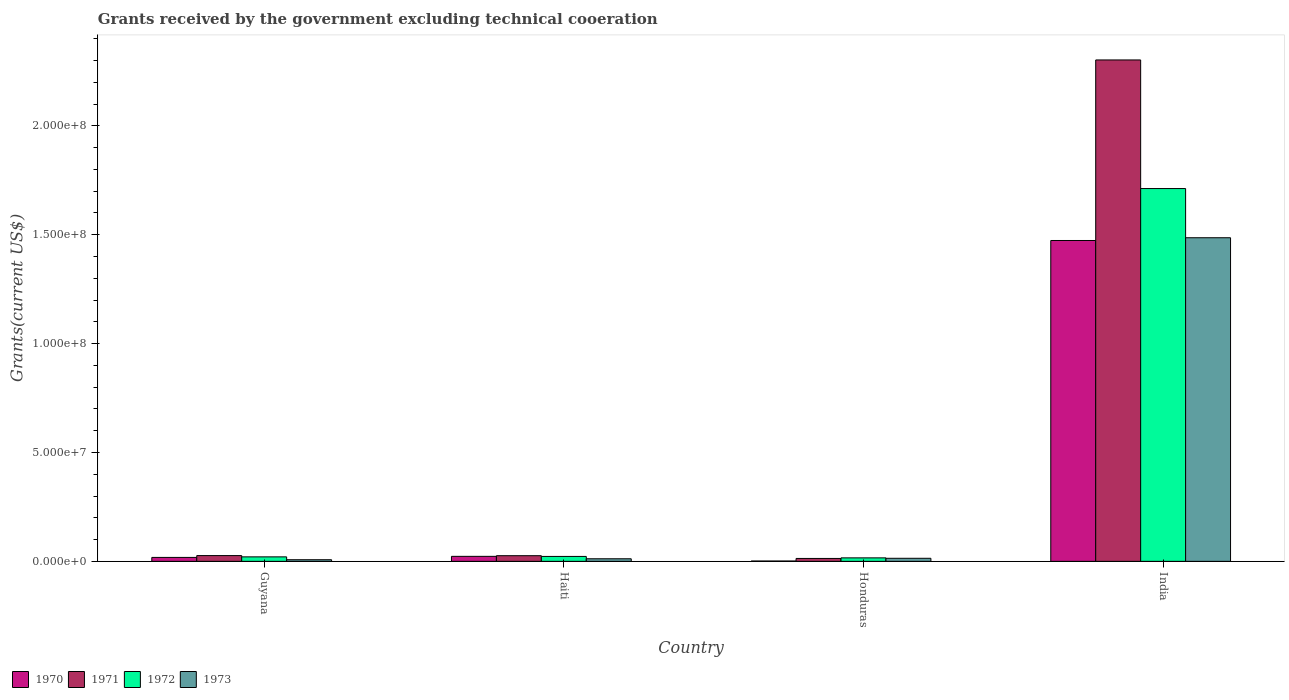How many different coloured bars are there?
Offer a very short reply. 4. What is the label of the 1st group of bars from the left?
Provide a succinct answer. Guyana. In how many cases, is the number of bars for a given country not equal to the number of legend labels?
Your answer should be compact. 0. What is the total grants received by the government in 1973 in Haiti?
Provide a short and direct response. 1.19e+06. Across all countries, what is the maximum total grants received by the government in 1973?
Your answer should be compact. 1.49e+08. Across all countries, what is the minimum total grants received by the government in 1971?
Your response must be concise. 1.34e+06. In which country was the total grants received by the government in 1973 maximum?
Provide a short and direct response. India. In which country was the total grants received by the government in 1973 minimum?
Make the answer very short. Guyana. What is the total total grants received by the government in 1970 in the graph?
Your response must be concise. 1.52e+08. What is the difference between the total grants received by the government in 1971 in Haiti and that in India?
Your answer should be very brief. -2.28e+08. What is the difference between the total grants received by the government in 1971 in Haiti and the total grants received by the government in 1972 in India?
Give a very brief answer. -1.69e+08. What is the average total grants received by the government in 1973 per country?
Provide a short and direct response. 3.80e+07. What is the ratio of the total grants received by the government in 1971 in Honduras to that in India?
Provide a short and direct response. 0.01. Is the total grants received by the government in 1971 in Guyana less than that in Haiti?
Give a very brief answer. No. What is the difference between the highest and the second highest total grants received by the government in 1973?
Offer a very short reply. 1.47e+08. What is the difference between the highest and the lowest total grants received by the government in 1972?
Provide a short and direct response. 1.70e+08. In how many countries, is the total grants received by the government in 1973 greater than the average total grants received by the government in 1973 taken over all countries?
Your answer should be very brief. 1. Is the sum of the total grants received by the government in 1971 in Haiti and India greater than the maximum total grants received by the government in 1972 across all countries?
Provide a short and direct response. Yes. How many bars are there?
Ensure brevity in your answer.  16. How many countries are there in the graph?
Provide a succinct answer. 4. What is the difference between two consecutive major ticks on the Y-axis?
Offer a very short reply. 5.00e+07. How many legend labels are there?
Give a very brief answer. 4. What is the title of the graph?
Offer a terse response. Grants received by the government excluding technical cooeration. What is the label or title of the Y-axis?
Ensure brevity in your answer.  Grants(current US$). What is the Grants(current US$) of 1970 in Guyana?
Give a very brief answer. 1.81e+06. What is the Grants(current US$) in 1971 in Guyana?
Your answer should be compact. 2.65e+06. What is the Grants(current US$) in 1972 in Guyana?
Your response must be concise. 2.06e+06. What is the Grants(current US$) in 1973 in Guyana?
Make the answer very short. 7.50e+05. What is the Grants(current US$) in 1970 in Haiti?
Provide a short and direct response. 2.30e+06. What is the Grants(current US$) in 1971 in Haiti?
Keep it short and to the point. 2.60e+06. What is the Grants(current US$) of 1972 in Haiti?
Provide a succinct answer. 2.26e+06. What is the Grants(current US$) in 1973 in Haiti?
Offer a very short reply. 1.19e+06. What is the Grants(current US$) in 1970 in Honduras?
Your answer should be very brief. 1.60e+05. What is the Grants(current US$) of 1971 in Honduras?
Make the answer very short. 1.34e+06. What is the Grants(current US$) of 1972 in Honduras?
Provide a short and direct response. 1.60e+06. What is the Grants(current US$) in 1973 in Honduras?
Provide a succinct answer. 1.41e+06. What is the Grants(current US$) of 1970 in India?
Make the answer very short. 1.47e+08. What is the Grants(current US$) of 1971 in India?
Provide a succinct answer. 2.30e+08. What is the Grants(current US$) in 1972 in India?
Give a very brief answer. 1.71e+08. What is the Grants(current US$) of 1973 in India?
Offer a very short reply. 1.49e+08. Across all countries, what is the maximum Grants(current US$) of 1970?
Your answer should be compact. 1.47e+08. Across all countries, what is the maximum Grants(current US$) in 1971?
Ensure brevity in your answer.  2.30e+08. Across all countries, what is the maximum Grants(current US$) of 1972?
Your response must be concise. 1.71e+08. Across all countries, what is the maximum Grants(current US$) of 1973?
Give a very brief answer. 1.49e+08. Across all countries, what is the minimum Grants(current US$) of 1970?
Ensure brevity in your answer.  1.60e+05. Across all countries, what is the minimum Grants(current US$) of 1971?
Give a very brief answer. 1.34e+06. Across all countries, what is the minimum Grants(current US$) in 1972?
Provide a short and direct response. 1.60e+06. Across all countries, what is the minimum Grants(current US$) in 1973?
Your response must be concise. 7.50e+05. What is the total Grants(current US$) in 1970 in the graph?
Your answer should be compact. 1.52e+08. What is the total Grants(current US$) in 1971 in the graph?
Provide a succinct answer. 2.37e+08. What is the total Grants(current US$) of 1972 in the graph?
Keep it short and to the point. 1.77e+08. What is the total Grants(current US$) in 1973 in the graph?
Offer a very short reply. 1.52e+08. What is the difference between the Grants(current US$) of 1970 in Guyana and that in Haiti?
Your answer should be very brief. -4.90e+05. What is the difference between the Grants(current US$) in 1971 in Guyana and that in Haiti?
Provide a succinct answer. 5.00e+04. What is the difference between the Grants(current US$) in 1973 in Guyana and that in Haiti?
Your response must be concise. -4.40e+05. What is the difference between the Grants(current US$) in 1970 in Guyana and that in Honduras?
Provide a short and direct response. 1.65e+06. What is the difference between the Grants(current US$) in 1971 in Guyana and that in Honduras?
Make the answer very short. 1.31e+06. What is the difference between the Grants(current US$) in 1973 in Guyana and that in Honduras?
Your answer should be very brief. -6.60e+05. What is the difference between the Grants(current US$) of 1970 in Guyana and that in India?
Give a very brief answer. -1.46e+08. What is the difference between the Grants(current US$) of 1971 in Guyana and that in India?
Your response must be concise. -2.28e+08. What is the difference between the Grants(current US$) in 1972 in Guyana and that in India?
Provide a succinct answer. -1.69e+08. What is the difference between the Grants(current US$) of 1973 in Guyana and that in India?
Offer a very short reply. -1.48e+08. What is the difference between the Grants(current US$) in 1970 in Haiti and that in Honduras?
Offer a terse response. 2.14e+06. What is the difference between the Grants(current US$) in 1971 in Haiti and that in Honduras?
Provide a succinct answer. 1.26e+06. What is the difference between the Grants(current US$) of 1972 in Haiti and that in Honduras?
Make the answer very short. 6.60e+05. What is the difference between the Grants(current US$) of 1970 in Haiti and that in India?
Your response must be concise. -1.45e+08. What is the difference between the Grants(current US$) of 1971 in Haiti and that in India?
Your answer should be compact. -2.28e+08. What is the difference between the Grants(current US$) of 1972 in Haiti and that in India?
Provide a short and direct response. -1.69e+08. What is the difference between the Grants(current US$) of 1973 in Haiti and that in India?
Give a very brief answer. -1.47e+08. What is the difference between the Grants(current US$) in 1970 in Honduras and that in India?
Offer a terse response. -1.47e+08. What is the difference between the Grants(current US$) of 1971 in Honduras and that in India?
Your answer should be very brief. -2.29e+08. What is the difference between the Grants(current US$) of 1972 in Honduras and that in India?
Give a very brief answer. -1.70e+08. What is the difference between the Grants(current US$) of 1973 in Honduras and that in India?
Keep it short and to the point. -1.47e+08. What is the difference between the Grants(current US$) of 1970 in Guyana and the Grants(current US$) of 1971 in Haiti?
Give a very brief answer. -7.90e+05. What is the difference between the Grants(current US$) in 1970 in Guyana and the Grants(current US$) in 1972 in Haiti?
Give a very brief answer. -4.50e+05. What is the difference between the Grants(current US$) of 1970 in Guyana and the Grants(current US$) of 1973 in Haiti?
Give a very brief answer. 6.20e+05. What is the difference between the Grants(current US$) in 1971 in Guyana and the Grants(current US$) in 1973 in Haiti?
Your answer should be very brief. 1.46e+06. What is the difference between the Grants(current US$) of 1972 in Guyana and the Grants(current US$) of 1973 in Haiti?
Provide a short and direct response. 8.70e+05. What is the difference between the Grants(current US$) of 1970 in Guyana and the Grants(current US$) of 1972 in Honduras?
Your answer should be compact. 2.10e+05. What is the difference between the Grants(current US$) of 1970 in Guyana and the Grants(current US$) of 1973 in Honduras?
Provide a succinct answer. 4.00e+05. What is the difference between the Grants(current US$) in 1971 in Guyana and the Grants(current US$) in 1972 in Honduras?
Make the answer very short. 1.05e+06. What is the difference between the Grants(current US$) in 1971 in Guyana and the Grants(current US$) in 1973 in Honduras?
Offer a very short reply. 1.24e+06. What is the difference between the Grants(current US$) in 1972 in Guyana and the Grants(current US$) in 1973 in Honduras?
Offer a terse response. 6.50e+05. What is the difference between the Grants(current US$) of 1970 in Guyana and the Grants(current US$) of 1971 in India?
Give a very brief answer. -2.28e+08. What is the difference between the Grants(current US$) of 1970 in Guyana and the Grants(current US$) of 1972 in India?
Offer a very short reply. -1.69e+08. What is the difference between the Grants(current US$) of 1970 in Guyana and the Grants(current US$) of 1973 in India?
Provide a succinct answer. -1.47e+08. What is the difference between the Grants(current US$) of 1971 in Guyana and the Grants(current US$) of 1972 in India?
Make the answer very short. -1.69e+08. What is the difference between the Grants(current US$) in 1971 in Guyana and the Grants(current US$) in 1973 in India?
Your answer should be compact. -1.46e+08. What is the difference between the Grants(current US$) of 1972 in Guyana and the Grants(current US$) of 1973 in India?
Your response must be concise. -1.47e+08. What is the difference between the Grants(current US$) in 1970 in Haiti and the Grants(current US$) in 1971 in Honduras?
Provide a succinct answer. 9.60e+05. What is the difference between the Grants(current US$) of 1970 in Haiti and the Grants(current US$) of 1972 in Honduras?
Your answer should be compact. 7.00e+05. What is the difference between the Grants(current US$) of 1970 in Haiti and the Grants(current US$) of 1973 in Honduras?
Provide a short and direct response. 8.90e+05. What is the difference between the Grants(current US$) in 1971 in Haiti and the Grants(current US$) in 1972 in Honduras?
Your answer should be compact. 1.00e+06. What is the difference between the Grants(current US$) of 1971 in Haiti and the Grants(current US$) of 1973 in Honduras?
Give a very brief answer. 1.19e+06. What is the difference between the Grants(current US$) of 1972 in Haiti and the Grants(current US$) of 1973 in Honduras?
Make the answer very short. 8.50e+05. What is the difference between the Grants(current US$) of 1970 in Haiti and the Grants(current US$) of 1971 in India?
Give a very brief answer. -2.28e+08. What is the difference between the Grants(current US$) of 1970 in Haiti and the Grants(current US$) of 1972 in India?
Make the answer very short. -1.69e+08. What is the difference between the Grants(current US$) in 1970 in Haiti and the Grants(current US$) in 1973 in India?
Ensure brevity in your answer.  -1.46e+08. What is the difference between the Grants(current US$) in 1971 in Haiti and the Grants(current US$) in 1972 in India?
Make the answer very short. -1.69e+08. What is the difference between the Grants(current US$) of 1971 in Haiti and the Grants(current US$) of 1973 in India?
Offer a very short reply. -1.46e+08. What is the difference between the Grants(current US$) in 1972 in Haiti and the Grants(current US$) in 1973 in India?
Your answer should be compact. -1.46e+08. What is the difference between the Grants(current US$) in 1970 in Honduras and the Grants(current US$) in 1971 in India?
Ensure brevity in your answer.  -2.30e+08. What is the difference between the Grants(current US$) of 1970 in Honduras and the Grants(current US$) of 1972 in India?
Provide a succinct answer. -1.71e+08. What is the difference between the Grants(current US$) in 1970 in Honduras and the Grants(current US$) in 1973 in India?
Provide a succinct answer. -1.48e+08. What is the difference between the Grants(current US$) of 1971 in Honduras and the Grants(current US$) of 1972 in India?
Make the answer very short. -1.70e+08. What is the difference between the Grants(current US$) in 1971 in Honduras and the Grants(current US$) in 1973 in India?
Ensure brevity in your answer.  -1.47e+08. What is the difference between the Grants(current US$) in 1972 in Honduras and the Grants(current US$) in 1973 in India?
Give a very brief answer. -1.47e+08. What is the average Grants(current US$) in 1970 per country?
Your answer should be compact. 3.79e+07. What is the average Grants(current US$) of 1971 per country?
Provide a succinct answer. 5.92e+07. What is the average Grants(current US$) of 1972 per country?
Provide a succinct answer. 4.43e+07. What is the average Grants(current US$) of 1973 per country?
Make the answer very short. 3.80e+07. What is the difference between the Grants(current US$) of 1970 and Grants(current US$) of 1971 in Guyana?
Your answer should be very brief. -8.40e+05. What is the difference between the Grants(current US$) in 1970 and Grants(current US$) in 1972 in Guyana?
Keep it short and to the point. -2.50e+05. What is the difference between the Grants(current US$) of 1970 and Grants(current US$) of 1973 in Guyana?
Give a very brief answer. 1.06e+06. What is the difference between the Grants(current US$) in 1971 and Grants(current US$) in 1972 in Guyana?
Make the answer very short. 5.90e+05. What is the difference between the Grants(current US$) of 1971 and Grants(current US$) of 1973 in Guyana?
Make the answer very short. 1.90e+06. What is the difference between the Grants(current US$) in 1972 and Grants(current US$) in 1973 in Guyana?
Provide a succinct answer. 1.31e+06. What is the difference between the Grants(current US$) in 1970 and Grants(current US$) in 1971 in Haiti?
Offer a very short reply. -3.00e+05. What is the difference between the Grants(current US$) in 1970 and Grants(current US$) in 1972 in Haiti?
Offer a terse response. 4.00e+04. What is the difference between the Grants(current US$) in 1970 and Grants(current US$) in 1973 in Haiti?
Ensure brevity in your answer.  1.11e+06. What is the difference between the Grants(current US$) of 1971 and Grants(current US$) of 1972 in Haiti?
Provide a short and direct response. 3.40e+05. What is the difference between the Grants(current US$) of 1971 and Grants(current US$) of 1973 in Haiti?
Your answer should be very brief. 1.41e+06. What is the difference between the Grants(current US$) in 1972 and Grants(current US$) in 1973 in Haiti?
Give a very brief answer. 1.07e+06. What is the difference between the Grants(current US$) in 1970 and Grants(current US$) in 1971 in Honduras?
Keep it short and to the point. -1.18e+06. What is the difference between the Grants(current US$) in 1970 and Grants(current US$) in 1972 in Honduras?
Make the answer very short. -1.44e+06. What is the difference between the Grants(current US$) of 1970 and Grants(current US$) of 1973 in Honduras?
Provide a succinct answer. -1.25e+06. What is the difference between the Grants(current US$) in 1970 and Grants(current US$) in 1971 in India?
Your response must be concise. -8.29e+07. What is the difference between the Grants(current US$) in 1970 and Grants(current US$) in 1972 in India?
Ensure brevity in your answer.  -2.38e+07. What is the difference between the Grants(current US$) in 1970 and Grants(current US$) in 1973 in India?
Offer a terse response. -1.26e+06. What is the difference between the Grants(current US$) in 1971 and Grants(current US$) in 1972 in India?
Offer a very short reply. 5.91e+07. What is the difference between the Grants(current US$) of 1971 and Grants(current US$) of 1973 in India?
Your answer should be compact. 8.16e+07. What is the difference between the Grants(current US$) in 1972 and Grants(current US$) in 1973 in India?
Your answer should be very brief. 2.26e+07. What is the ratio of the Grants(current US$) of 1970 in Guyana to that in Haiti?
Keep it short and to the point. 0.79. What is the ratio of the Grants(current US$) in 1971 in Guyana to that in Haiti?
Offer a terse response. 1.02. What is the ratio of the Grants(current US$) in 1972 in Guyana to that in Haiti?
Offer a terse response. 0.91. What is the ratio of the Grants(current US$) of 1973 in Guyana to that in Haiti?
Ensure brevity in your answer.  0.63. What is the ratio of the Grants(current US$) in 1970 in Guyana to that in Honduras?
Keep it short and to the point. 11.31. What is the ratio of the Grants(current US$) in 1971 in Guyana to that in Honduras?
Offer a very short reply. 1.98. What is the ratio of the Grants(current US$) of 1972 in Guyana to that in Honduras?
Your answer should be very brief. 1.29. What is the ratio of the Grants(current US$) in 1973 in Guyana to that in Honduras?
Ensure brevity in your answer.  0.53. What is the ratio of the Grants(current US$) in 1970 in Guyana to that in India?
Your answer should be compact. 0.01. What is the ratio of the Grants(current US$) in 1971 in Guyana to that in India?
Make the answer very short. 0.01. What is the ratio of the Grants(current US$) in 1972 in Guyana to that in India?
Keep it short and to the point. 0.01. What is the ratio of the Grants(current US$) of 1973 in Guyana to that in India?
Provide a short and direct response. 0.01. What is the ratio of the Grants(current US$) of 1970 in Haiti to that in Honduras?
Keep it short and to the point. 14.38. What is the ratio of the Grants(current US$) in 1971 in Haiti to that in Honduras?
Make the answer very short. 1.94. What is the ratio of the Grants(current US$) in 1972 in Haiti to that in Honduras?
Provide a succinct answer. 1.41. What is the ratio of the Grants(current US$) of 1973 in Haiti to that in Honduras?
Provide a succinct answer. 0.84. What is the ratio of the Grants(current US$) of 1970 in Haiti to that in India?
Your answer should be compact. 0.02. What is the ratio of the Grants(current US$) in 1971 in Haiti to that in India?
Your answer should be compact. 0.01. What is the ratio of the Grants(current US$) in 1972 in Haiti to that in India?
Provide a short and direct response. 0.01. What is the ratio of the Grants(current US$) in 1973 in Haiti to that in India?
Offer a very short reply. 0.01. What is the ratio of the Grants(current US$) of 1970 in Honduras to that in India?
Keep it short and to the point. 0. What is the ratio of the Grants(current US$) in 1971 in Honduras to that in India?
Provide a short and direct response. 0.01. What is the ratio of the Grants(current US$) of 1972 in Honduras to that in India?
Your response must be concise. 0.01. What is the ratio of the Grants(current US$) in 1973 in Honduras to that in India?
Make the answer very short. 0.01. What is the difference between the highest and the second highest Grants(current US$) of 1970?
Provide a succinct answer. 1.45e+08. What is the difference between the highest and the second highest Grants(current US$) in 1971?
Your answer should be very brief. 2.28e+08. What is the difference between the highest and the second highest Grants(current US$) in 1972?
Provide a succinct answer. 1.69e+08. What is the difference between the highest and the second highest Grants(current US$) of 1973?
Provide a short and direct response. 1.47e+08. What is the difference between the highest and the lowest Grants(current US$) of 1970?
Offer a very short reply. 1.47e+08. What is the difference between the highest and the lowest Grants(current US$) of 1971?
Give a very brief answer. 2.29e+08. What is the difference between the highest and the lowest Grants(current US$) of 1972?
Your answer should be compact. 1.70e+08. What is the difference between the highest and the lowest Grants(current US$) in 1973?
Your answer should be compact. 1.48e+08. 